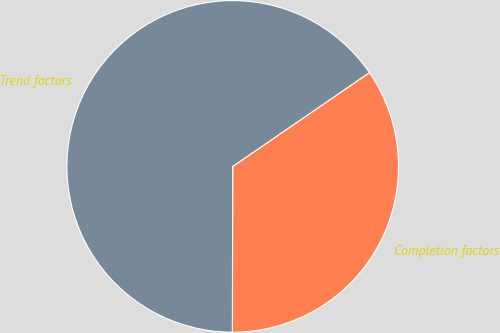Convert chart to OTSL. <chart><loc_0><loc_0><loc_500><loc_500><pie_chart><fcel>Completion factors<fcel>Trend factors<nl><fcel>34.61%<fcel>65.39%<nl></chart> 